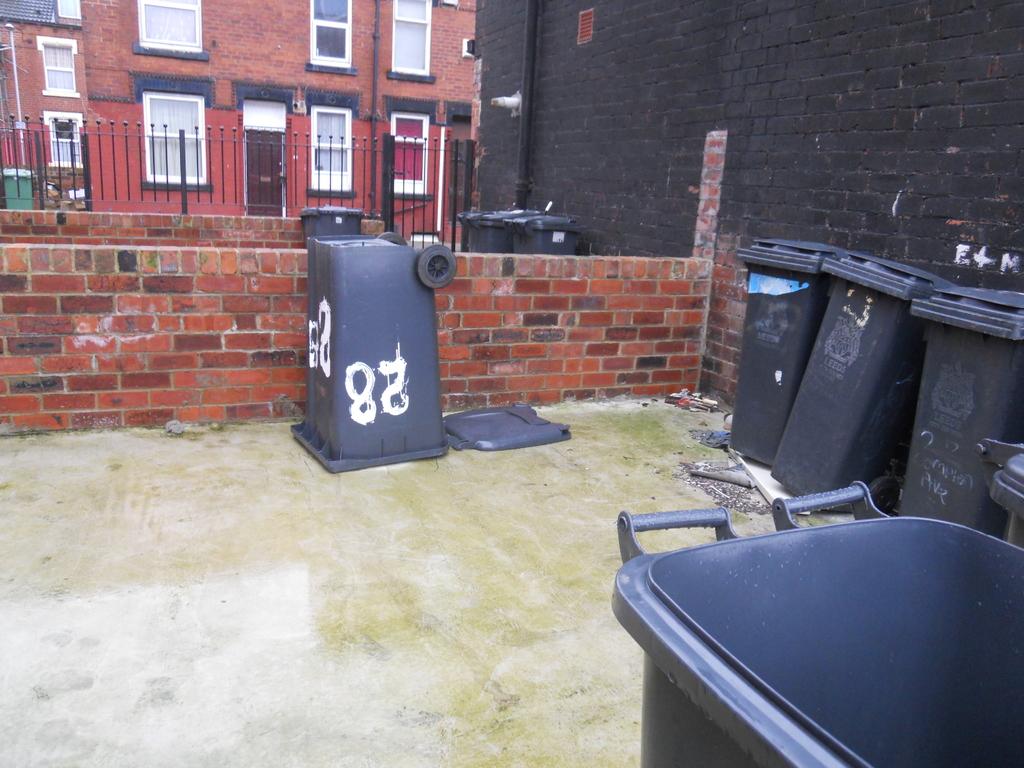What number is written upside down on the trash can?
Keep it short and to the point. 28. 